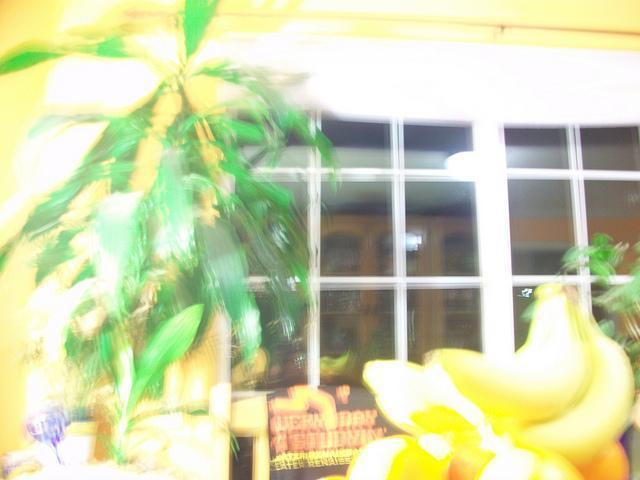How many bananas can be seen?
Give a very brief answer. 2. 